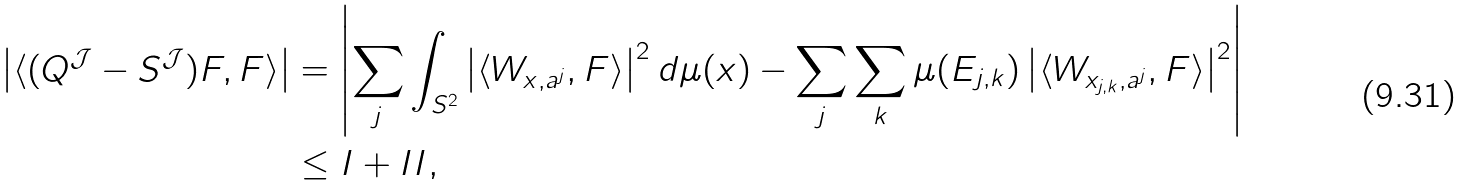<formula> <loc_0><loc_0><loc_500><loc_500>\left | \langle ( Q ^ { \mathcal { J } } - S ^ { \mathcal { J } } ) F , F \rangle \right | & = \left | \sum _ { j } \int _ { S ^ { 2 } } \left | \langle W _ { x , a ^ { j } } , F \rangle \right | ^ { 2 } d \mu ( x ) - \sum _ { j } \sum _ { k } \mu ( E _ { j , k } ) \left | \langle W _ { x _ { j , k } , a ^ { j } } , F \rangle \right | ^ { 2 } \right | \\ & \leq I + I I ,</formula> 